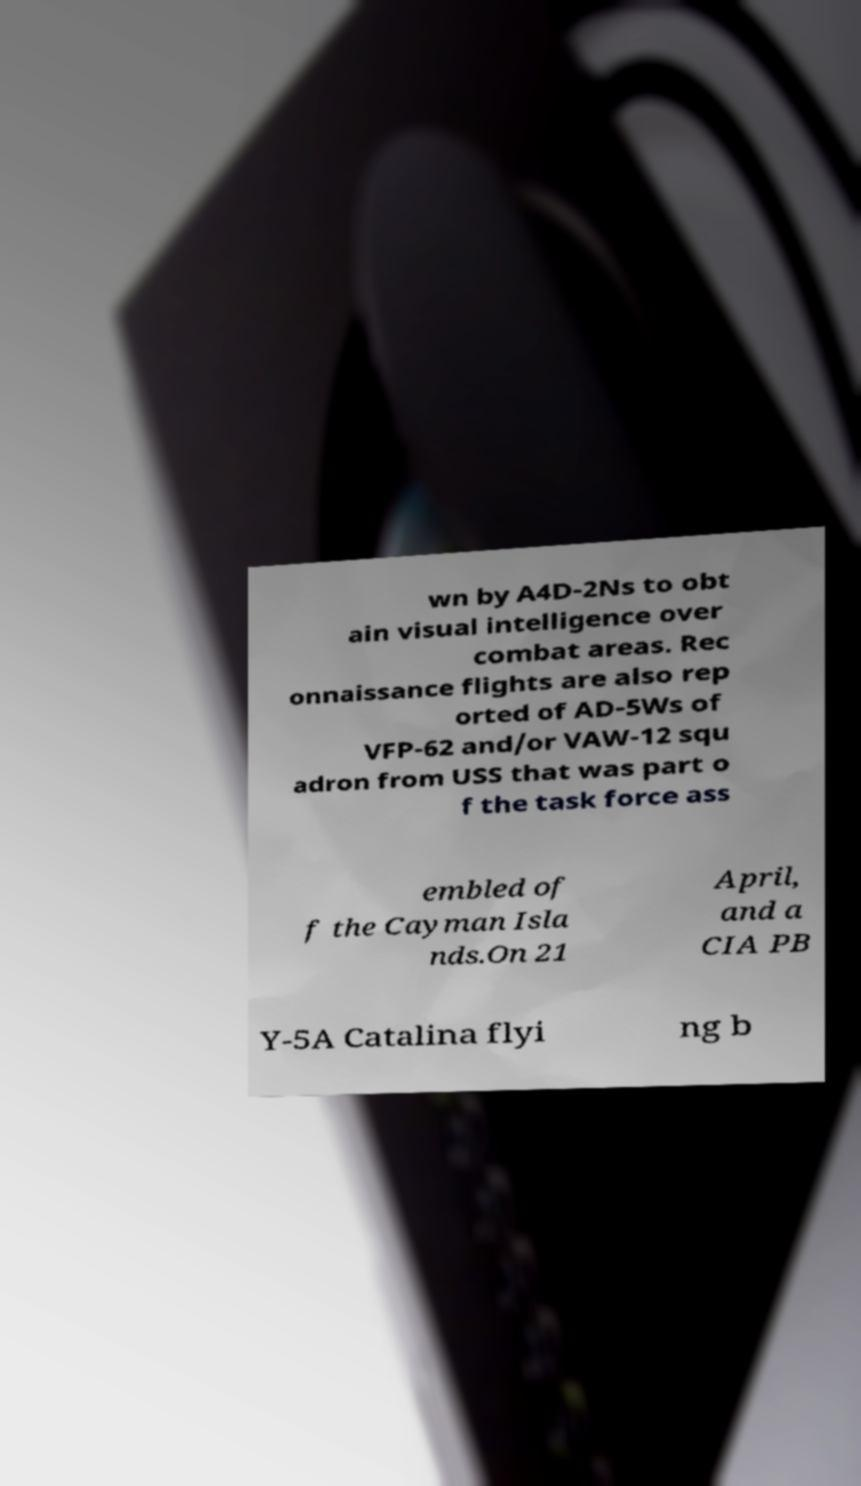Please identify and transcribe the text found in this image. wn by A4D-2Ns to obt ain visual intelligence over combat areas. Rec onnaissance flights are also rep orted of AD-5Ws of VFP-62 and/or VAW-12 squ adron from USS that was part o f the task force ass embled of f the Cayman Isla nds.On 21 April, and a CIA PB Y-5A Catalina flyi ng b 